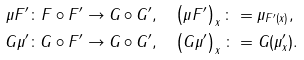<formula> <loc_0><loc_0><loc_500><loc_500>\mu F ^ { \prime } \colon F \circ F ^ { \prime } \rightarrow G \circ G ^ { \prime } & , \quad \left ( \mu F ^ { \prime } \right ) _ { x } \colon = \mu _ { F ^ { \prime } ( x ) } , \\ G \mu ^ { \prime } \colon G \circ F ^ { \prime } \rightarrow G \circ G ^ { \prime } & , \quad \left ( G \mu ^ { \prime } \right ) _ { x } \colon = G ( \mu _ { x } ^ { \prime } ) .</formula> 